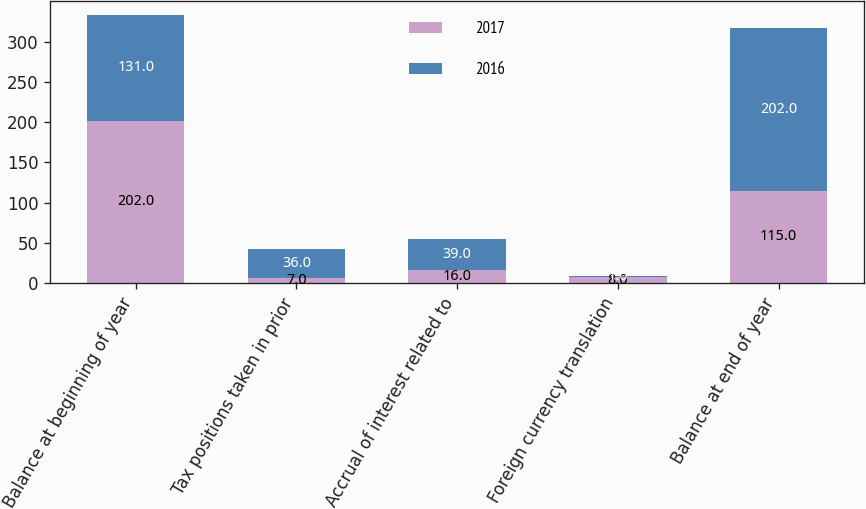Convert chart. <chart><loc_0><loc_0><loc_500><loc_500><stacked_bar_chart><ecel><fcel>Balance at beginning of year<fcel>Tax positions taken in prior<fcel>Accrual of interest related to<fcel>Foreign currency translation<fcel>Balance at end of year<nl><fcel>2017<fcel>202<fcel>7<fcel>16<fcel>8<fcel>115<nl><fcel>2016<fcel>131<fcel>36<fcel>39<fcel>1<fcel>202<nl></chart> 